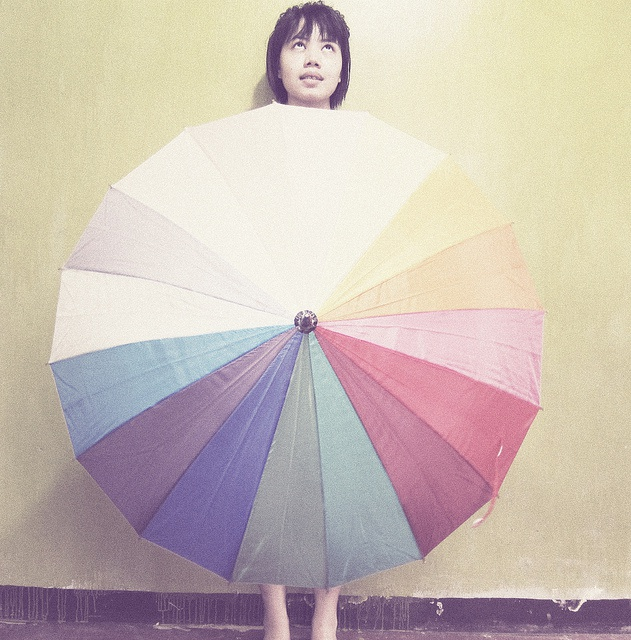Describe the objects in this image and their specific colors. I can see umbrella in beige, ivory, darkgray, gray, and lightpink tones and people in beige, purple, lightgray, pink, and darkgray tones in this image. 